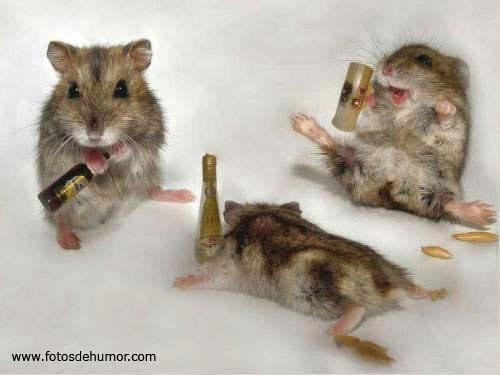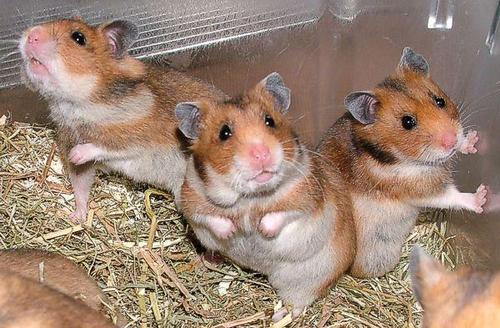The first image is the image on the left, the second image is the image on the right. Given the left and right images, does the statement "One of the images shows hamsters crowded inside a container that has ears on top of it." hold true? Answer yes or no. No. 